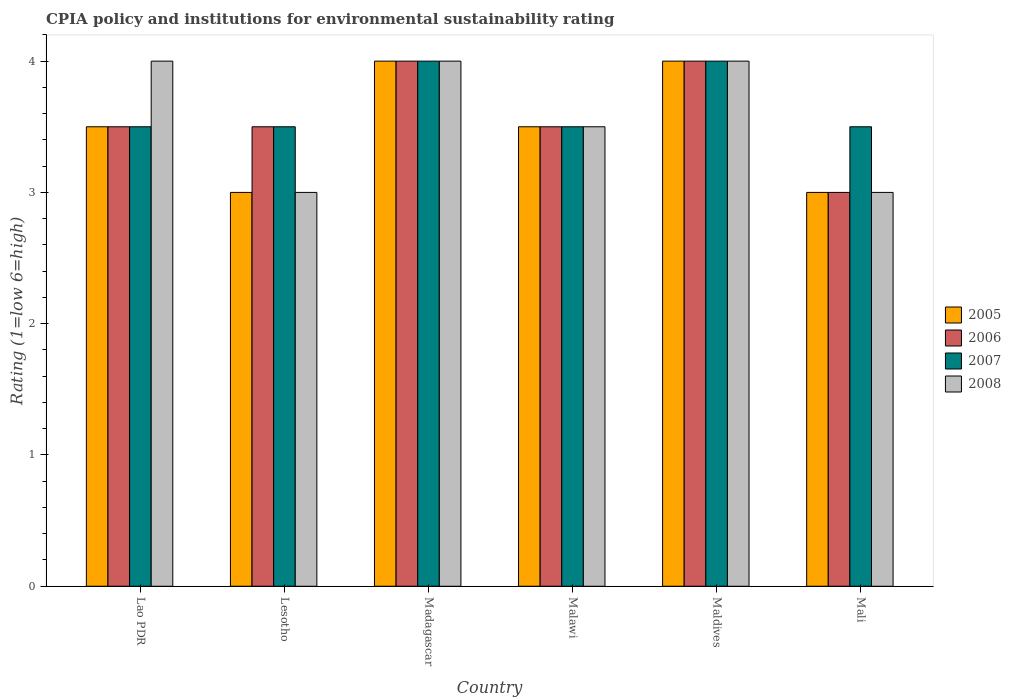How many different coloured bars are there?
Provide a short and direct response. 4. Are the number of bars on each tick of the X-axis equal?
Provide a succinct answer. Yes. How many bars are there on the 5th tick from the left?
Your answer should be compact. 4. How many bars are there on the 5th tick from the right?
Make the answer very short. 4. What is the label of the 4th group of bars from the left?
Offer a very short reply. Malawi. What is the CPIA rating in 2008 in Mali?
Offer a very short reply. 3. In which country was the CPIA rating in 2006 maximum?
Offer a terse response. Madagascar. In which country was the CPIA rating in 2008 minimum?
Give a very brief answer. Lesotho. What is the total CPIA rating in 2005 in the graph?
Keep it short and to the point. 21. What is the difference between the CPIA rating in 2006 in Madagascar and that in Maldives?
Your response must be concise. 0. What is the difference between the CPIA rating in 2007 in Lesotho and the CPIA rating in 2008 in Madagascar?
Give a very brief answer. -0.5. What is the average CPIA rating in 2007 per country?
Your answer should be compact. 3.67. What is the ratio of the CPIA rating in 2006 in Lao PDR to that in Madagascar?
Offer a very short reply. 0.88. Is the difference between the CPIA rating in 2005 in Madagascar and Malawi greater than the difference between the CPIA rating in 2007 in Madagascar and Malawi?
Make the answer very short. No. Is it the case that in every country, the sum of the CPIA rating in 2006 and CPIA rating in 2007 is greater than the sum of CPIA rating in 2005 and CPIA rating in 2008?
Ensure brevity in your answer.  No. What does the 3rd bar from the left in Lao PDR represents?
Keep it short and to the point. 2007. How many bars are there?
Your answer should be very brief. 24. Are all the bars in the graph horizontal?
Provide a short and direct response. No. How many countries are there in the graph?
Offer a terse response. 6. What is the difference between two consecutive major ticks on the Y-axis?
Provide a succinct answer. 1. Are the values on the major ticks of Y-axis written in scientific E-notation?
Your answer should be very brief. No. Does the graph contain any zero values?
Ensure brevity in your answer.  No. Does the graph contain grids?
Give a very brief answer. No. How many legend labels are there?
Offer a terse response. 4. How are the legend labels stacked?
Your answer should be compact. Vertical. What is the title of the graph?
Keep it short and to the point. CPIA policy and institutions for environmental sustainability rating. Does "1990" appear as one of the legend labels in the graph?
Your answer should be very brief. No. What is the label or title of the X-axis?
Ensure brevity in your answer.  Country. What is the label or title of the Y-axis?
Give a very brief answer. Rating (1=low 6=high). What is the Rating (1=low 6=high) of 2005 in Lao PDR?
Keep it short and to the point. 3.5. What is the Rating (1=low 6=high) in 2006 in Lao PDR?
Ensure brevity in your answer.  3.5. What is the Rating (1=low 6=high) in 2008 in Lao PDR?
Offer a very short reply. 4. What is the Rating (1=low 6=high) of 2005 in Lesotho?
Your answer should be very brief. 3. What is the Rating (1=low 6=high) of 2006 in Lesotho?
Make the answer very short. 3.5. What is the Rating (1=low 6=high) of 2007 in Lesotho?
Keep it short and to the point. 3.5. What is the Rating (1=low 6=high) in 2006 in Madagascar?
Give a very brief answer. 4. What is the Rating (1=low 6=high) of 2008 in Madagascar?
Provide a succinct answer. 4. What is the Rating (1=low 6=high) in 2007 in Malawi?
Ensure brevity in your answer.  3.5. What is the Rating (1=low 6=high) in 2008 in Maldives?
Give a very brief answer. 4. What is the Rating (1=low 6=high) in 2006 in Mali?
Ensure brevity in your answer.  3. What is the Rating (1=low 6=high) in 2007 in Mali?
Provide a short and direct response. 3.5. What is the Rating (1=low 6=high) of 2008 in Mali?
Ensure brevity in your answer.  3. Across all countries, what is the maximum Rating (1=low 6=high) in 2005?
Make the answer very short. 4. Across all countries, what is the maximum Rating (1=low 6=high) in 2008?
Your response must be concise. 4. Across all countries, what is the minimum Rating (1=low 6=high) in 2005?
Offer a very short reply. 3. Across all countries, what is the minimum Rating (1=low 6=high) in 2006?
Your answer should be very brief. 3. What is the total Rating (1=low 6=high) in 2005 in the graph?
Make the answer very short. 21. What is the total Rating (1=low 6=high) of 2006 in the graph?
Ensure brevity in your answer.  21.5. What is the difference between the Rating (1=low 6=high) in 2005 in Lao PDR and that in Lesotho?
Your answer should be very brief. 0.5. What is the difference between the Rating (1=low 6=high) of 2008 in Lao PDR and that in Lesotho?
Offer a terse response. 1. What is the difference between the Rating (1=low 6=high) in 2005 in Lao PDR and that in Madagascar?
Offer a very short reply. -0.5. What is the difference between the Rating (1=low 6=high) of 2007 in Lao PDR and that in Madagascar?
Your answer should be very brief. -0.5. What is the difference between the Rating (1=low 6=high) in 2006 in Lao PDR and that in Malawi?
Provide a short and direct response. 0. What is the difference between the Rating (1=low 6=high) of 2007 in Lao PDR and that in Malawi?
Provide a succinct answer. 0. What is the difference between the Rating (1=low 6=high) in 2008 in Lao PDR and that in Maldives?
Give a very brief answer. 0. What is the difference between the Rating (1=low 6=high) of 2005 in Lao PDR and that in Mali?
Offer a terse response. 0.5. What is the difference between the Rating (1=low 6=high) of 2006 in Lao PDR and that in Mali?
Give a very brief answer. 0.5. What is the difference between the Rating (1=low 6=high) in 2005 in Lesotho and that in Madagascar?
Provide a succinct answer. -1. What is the difference between the Rating (1=low 6=high) of 2007 in Lesotho and that in Madagascar?
Provide a short and direct response. -0.5. What is the difference between the Rating (1=low 6=high) in 2005 in Lesotho and that in Malawi?
Your answer should be very brief. -0.5. What is the difference between the Rating (1=low 6=high) in 2007 in Lesotho and that in Malawi?
Ensure brevity in your answer.  0. What is the difference between the Rating (1=low 6=high) in 2006 in Lesotho and that in Maldives?
Your response must be concise. -0.5. What is the difference between the Rating (1=low 6=high) in 2007 in Lesotho and that in Mali?
Offer a very short reply. 0. What is the difference between the Rating (1=low 6=high) of 2008 in Lesotho and that in Mali?
Ensure brevity in your answer.  0. What is the difference between the Rating (1=low 6=high) in 2006 in Madagascar and that in Malawi?
Your answer should be compact. 0.5. What is the difference between the Rating (1=low 6=high) of 2007 in Madagascar and that in Malawi?
Give a very brief answer. 0.5. What is the difference between the Rating (1=low 6=high) in 2008 in Madagascar and that in Malawi?
Provide a succinct answer. 0.5. What is the difference between the Rating (1=low 6=high) in 2006 in Madagascar and that in Maldives?
Keep it short and to the point. 0. What is the difference between the Rating (1=low 6=high) in 2007 in Madagascar and that in Maldives?
Provide a succinct answer. 0. What is the difference between the Rating (1=low 6=high) of 2008 in Madagascar and that in Mali?
Offer a terse response. 1. What is the difference between the Rating (1=low 6=high) in 2005 in Malawi and that in Maldives?
Keep it short and to the point. -0.5. What is the difference between the Rating (1=low 6=high) in 2006 in Malawi and that in Maldives?
Offer a very short reply. -0.5. What is the difference between the Rating (1=low 6=high) in 2008 in Malawi and that in Maldives?
Provide a succinct answer. -0.5. What is the difference between the Rating (1=low 6=high) in 2005 in Malawi and that in Mali?
Give a very brief answer. 0.5. What is the difference between the Rating (1=low 6=high) in 2006 in Malawi and that in Mali?
Offer a very short reply. 0.5. What is the difference between the Rating (1=low 6=high) of 2007 in Malawi and that in Mali?
Provide a succinct answer. 0. What is the difference between the Rating (1=low 6=high) of 2008 in Malawi and that in Mali?
Provide a succinct answer. 0.5. What is the difference between the Rating (1=low 6=high) in 2005 in Lao PDR and the Rating (1=low 6=high) in 2006 in Lesotho?
Provide a short and direct response. 0. What is the difference between the Rating (1=low 6=high) in 2005 in Lao PDR and the Rating (1=low 6=high) in 2007 in Madagascar?
Your answer should be very brief. -0.5. What is the difference between the Rating (1=low 6=high) in 2006 in Lao PDR and the Rating (1=low 6=high) in 2008 in Madagascar?
Make the answer very short. -0.5. What is the difference between the Rating (1=low 6=high) in 2007 in Lao PDR and the Rating (1=low 6=high) in 2008 in Madagascar?
Your answer should be very brief. -0.5. What is the difference between the Rating (1=low 6=high) in 2005 in Lao PDR and the Rating (1=low 6=high) in 2007 in Malawi?
Your response must be concise. 0. What is the difference between the Rating (1=low 6=high) in 2006 in Lao PDR and the Rating (1=low 6=high) in 2008 in Malawi?
Keep it short and to the point. 0. What is the difference between the Rating (1=low 6=high) in 2006 in Lao PDR and the Rating (1=low 6=high) in 2008 in Maldives?
Your answer should be very brief. -0.5. What is the difference between the Rating (1=low 6=high) in 2007 in Lao PDR and the Rating (1=low 6=high) in 2008 in Maldives?
Offer a very short reply. -0.5. What is the difference between the Rating (1=low 6=high) of 2005 in Lao PDR and the Rating (1=low 6=high) of 2007 in Mali?
Your answer should be compact. 0. What is the difference between the Rating (1=low 6=high) of 2005 in Lao PDR and the Rating (1=low 6=high) of 2008 in Mali?
Make the answer very short. 0.5. What is the difference between the Rating (1=low 6=high) in 2006 in Lao PDR and the Rating (1=low 6=high) in 2007 in Mali?
Your response must be concise. 0. What is the difference between the Rating (1=low 6=high) in 2006 in Lao PDR and the Rating (1=low 6=high) in 2008 in Mali?
Provide a short and direct response. 0.5. What is the difference between the Rating (1=low 6=high) in 2007 in Lao PDR and the Rating (1=low 6=high) in 2008 in Mali?
Make the answer very short. 0.5. What is the difference between the Rating (1=low 6=high) of 2005 in Lesotho and the Rating (1=low 6=high) of 2006 in Madagascar?
Your response must be concise. -1. What is the difference between the Rating (1=low 6=high) in 2005 in Lesotho and the Rating (1=low 6=high) in 2007 in Madagascar?
Your response must be concise. -1. What is the difference between the Rating (1=low 6=high) of 2005 in Lesotho and the Rating (1=low 6=high) of 2008 in Madagascar?
Provide a short and direct response. -1. What is the difference between the Rating (1=low 6=high) of 2006 in Lesotho and the Rating (1=low 6=high) of 2008 in Madagascar?
Your response must be concise. -0.5. What is the difference between the Rating (1=low 6=high) in 2005 in Lesotho and the Rating (1=low 6=high) in 2007 in Malawi?
Provide a short and direct response. -0.5. What is the difference between the Rating (1=low 6=high) in 2005 in Lesotho and the Rating (1=low 6=high) in 2008 in Malawi?
Offer a terse response. -0.5. What is the difference between the Rating (1=low 6=high) of 2006 in Lesotho and the Rating (1=low 6=high) of 2008 in Malawi?
Provide a succinct answer. 0. What is the difference between the Rating (1=low 6=high) of 2007 in Lesotho and the Rating (1=low 6=high) of 2008 in Malawi?
Your response must be concise. 0. What is the difference between the Rating (1=low 6=high) of 2005 in Lesotho and the Rating (1=low 6=high) of 2007 in Maldives?
Offer a terse response. -1. What is the difference between the Rating (1=low 6=high) in 2006 in Lesotho and the Rating (1=low 6=high) in 2007 in Maldives?
Give a very brief answer. -0.5. What is the difference between the Rating (1=low 6=high) of 2006 in Lesotho and the Rating (1=low 6=high) of 2008 in Maldives?
Your response must be concise. -0.5. What is the difference between the Rating (1=low 6=high) of 2005 in Lesotho and the Rating (1=low 6=high) of 2006 in Mali?
Give a very brief answer. 0. What is the difference between the Rating (1=low 6=high) in 2005 in Lesotho and the Rating (1=low 6=high) in 2007 in Mali?
Offer a very short reply. -0.5. What is the difference between the Rating (1=low 6=high) in 2007 in Lesotho and the Rating (1=low 6=high) in 2008 in Mali?
Your answer should be compact. 0.5. What is the difference between the Rating (1=low 6=high) of 2005 in Madagascar and the Rating (1=low 6=high) of 2006 in Malawi?
Your answer should be compact. 0.5. What is the difference between the Rating (1=low 6=high) of 2005 in Madagascar and the Rating (1=low 6=high) of 2007 in Malawi?
Make the answer very short. 0.5. What is the difference between the Rating (1=low 6=high) of 2005 in Madagascar and the Rating (1=low 6=high) of 2008 in Malawi?
Provide a succinct answer. 0.5. What is the difference between the Rating (1=low 6=high) of 2006 in Madagascar and the Rating (1=low 6=high) of 2007 in Maldives?
Your answer should be compact. 0. What is the difference between the Rating (1=low 6=high) in 2006 in Madagascar and the Rating (1=low 6=high) in 2008 in Maldives?
Give a very brief answer. 0. What is the difference between the Rating (1=low 6=high) of 2005 in Madagascar and the Rating (1=low 6=high) of 2008 in Mali?
Keep it short and to the point. 1. What is the difference between the Rating (1=low 6=high) in 2006 in Madagascar and the Rating (1=low 6=high) in 2007 in Mali?
Make the answer very short. 0.5. What is the difference between the Rating (1=low 6=high) in 2006 in Madagascar and the Rating (1=low 6=high) in 2008 in Mali?
Your answer should be compact. 1. What is the difference between the Rating (1=low 6=high) of 2005 in Malawi and the Rating (1=low 6=high) of 2006 in Maldives?
Give a very brief answer. -0.5. What is the difference between the Rating (1=low 6=high) in 2005 in Malawi and the Rating (1=low 6=high) in 2007 in Maldives?
Ensure brevity in your answer.  -0.5. What is the difference between the Rating (1=low 6=high) in 2005 in Malawi and the Rating (1=low 6=high) in 2008 in Maldives?
Keep it short and to the point. -0.5. What is the difference between the Rating (1=low 6=high) of 2005 in Malawi and the Rating (1=low 6=high) of 2007 in Mali?
Ensure brevity in your answer.  0. What is the difference between the Rating (1=low 6=high) in 2006 in Malawi and the Rating (1=low 6=high) in 2007 in Mali?
Offer a very short reply. 0. What is the difference between the Rating (1=low 6=high) in 2006 in Malawi and the Rating (1=low 6=high) in 2008 in Mali?
Your answer should be very brief. 0.5. What is the difference between the Rating (1=low 6=high) of 2005 in Maldives and the Rating (1=low 6=high) of 2008 in Mali?
Ensure brevity in your answer.  1. What is the difference between the Rating (1=low 6=high) in 2006 in Maldives and the Rating (1=low 6=high) in 2008 in Mali?
Your answer should be compact. 1. What is the average Rating (1=low 6=high) of 2005 per country?
Your answer should be very brief. 3.5. What is the average Rating (1=low 6=high) of 2006 per country?
Your response must be concise. 3.58. What is the average Rating (1=low 6=high) of 2007 per country?
Provide a succinct answer. 3.67. What is the average Rating (1=low 6=high) in 2008 per country?
Provide a succinct answer. 3.58. What is the difference between the Rating (1=low 6=high) of 2005 and Rating (1=low 6=high) of 2006 in Lao PDR?
Provide a succinct answer. 0. What is the difference between the Rating (1=low 6=high) in 2005 and Rating (1=low 6=high) in 2007 in Lao PDR?
Keep it short and to the point. 0. What is the difference between the Rating (1=low 6=high) of 2005 and Rating (1=low 6=high) of 2008 in Lao PDR?
Give a very brief answer. -0.5. What is the difference between the Rating (1=low 6=high) in 2006 and Rating (1=low 6=high) in 2007 in Lao PDR?
Your response must be concise. 0. What is the difference between the Rating (1=low 6=high) of 2007 and Rating (1=low 6=high) of 2008 in Lao PDR?
Provide a short and direct response. -0.5. What is the difference between the Rating (1=low 6=high) in 2005 and Rating (1=low 6=high) in 2008 in Lesotho?
Give a very brief answer. 0. What is the difference between the Rating (1=low 6=high) of 2006 and Rating (1=low 6=high) of 2007 in Lesotho?
Provide a short and direct response. 0. What is the difference between the Rating (1=low 6=high) in 2007 and Rating (1=low 6=high) in 2008 in Lesotho?
Make the answer very short. 0.5. What is the difference between the Rating (1=low 6=high) of 2006 and Rating (1=low 6=high) of 2007 in Madagascar?
Offer a very short reply. 0. What is the difference between the Rating (1=low 6=high) of 2006 and Rating (1=low 6=high) of 2008 in Madagascar?
Keep it short and to the point. 0. What is the difference between the Rating (1=low 6=high) in 2006 and Rating (1=low 6=high) in 2007 in Malawi?
Provide a succinct answer. 0. What is the difference between the Rating (1=low 6=high) in 2006 and Rating (1=low 6=high) in 2008 in Malawi?
Keep it short and to the point. 0. What is the difference between the Rating (1=low 6=high) of 2007 and Rating (1=low 6=high) of 2008 in Malawi?
Your answer should be compact. 0. What is the difference between the Rating (1=low 6=high) in 2006 and Rating (1=low 6=high) in 2008 in Maldives?
Your answer should be compact. 0. What is the difference between the Rating (1=low 6=high) in 2005 and Rating (1=low 6=high) in 2007 in Mali?
Keep it short and to the point. -0.5. What is the difference between the Rating (1=low 6=high) of 2005 and Rating (1=low 6=high) of 2008 in Mali?
Your answer should be compact. 0. What is the difference between the Rating (1=low 6=high) of 2007 and Rating (1=low 6=high) of 2008 in Mali?
Offer a terse response. 0.5. What is the ratio of the Rating (1=low 6=high) of 2006 in Lao PDR to that in Lesotho?
Your answer should be very brief. 1. What is the ratio of the Rating (1=low 6=high) in 2005 in Lao PDR to that in Madagascar?
Offer a very short reply. 0.88. What is the ratio of the Rating (1=low 6=high) in 2005 in Lao PDR to that in Malawi?
Make the answer very short. 1. What is the ratio of the Rating (1=low 6=high) of 2006 in Lao PDR to that in Malawi?
Give a very brief answer. 1. What is the ratio of the Rating (1=low 6=high) in 2006 in Lao PDR to that in Maldives?
Your answer should be compact. 0.88. What is the ratio of the Rating (1=low 6=high) of 2008 in Lao PDR to that in Maldives?
Keep it short and to the point. 1. What is the ratio of the Rating (1=low 6=high) in 2005 in Lao PDR to that in Mali?
Your answer should be very brief. 1.17. What is the ratio of the Rating (1=low 6=high) of 2006 in Lao PDR to that in Mali?
Provide a succinct answer. 1.17. What is the ratio of the Rating (1=low 6=high) of 2007 in Lao PDR to that in Mali?
Your response must be concise. 1. What is the ratio of the Rating (1=low 6=high) of 2008 in Lesotho to that in Madagascar?
Provide a short and direct response. 0.75. What is the ratio of the Rating (1=low 6=high) in 2005 in Lesotho to that in Malawi?
Make the answer very short. 0.86. What is the ratio of the Rating (1=low 6=high) in 2008 in Lesotho to that in Malawi?
Ensure brevity in your answer.  0.86. What is the ratio of the Rating (1=low 6=high) of 2006 in Lesotho to that in Maldives?
Your response must be concise. 0.88. What is the ratio of the Rating (1=low 6=high) in 2007 in Lesotho to that in Maldives?
Provide a succinct answer. 0.88. What is the ratio of the Rating (1=low 6=high) of 2005 in Lesotho to that in Mali?
Make the answer very short. 1. What is the ratio of the Rating (1=low 6=high) of 2007 in Lesotho to that in Mali?
Your answer should be very brief. 1. What is the ratio of the Rating (1=low 6=high) of 2008 in Lesotho to that in Mali?
Provide a succinct answer. 1. What is the ratio of the Rating (1=low 6=high) of 2005 in Madagascar to that in Malawi?
Keep it short and to the point. 1.14. What is the ratio of the Rating (1=low 6=high) in 2006 in Madagascar to that in Malawi?
Provide a succinct answer. 1.14. What is the ratio of the Rating (1=low 6=high) of 2005 in Madagascar to that in Maldives?
Provide a short and direct response. 1. What is the ratio of the Rating (1=low 6=high) in 2006 in Madagascar to that in Maldives?
Offer a very short reply. 1. What is the ratio of the Rating (1=low 6=high) of 2007 in Madagascar to that in Maldives?
Make the answer very short. 1. What is the ratio of the Rating (1=low 6=high) of 2008 in Madagascar to that in Maldives?
Give a very brief answer. 1. What is the ratio of the Rating (1=low 6=high) in 2005 in Madagascar to that in Mali?
Ensure brevity in your answer.  1.33. What is the ratio of the Rating (1=low 6=high) in 2008 in Madagascar to that in Mali?
Provide a short and direct response. 1.33. What is the ratio of the Rating (1=low 6=high) of 2005 in Malawi to that in Maldives?
Give a very brief answer. 0.88. What is the ratio of the Rating (1=low 6=high) of 2005 in Malawi to that in Mali?
Make the answer very short. 1.17. What is the ratio of the Rating (1=low 6=high) in 2005 in Maldives to that in Mali?
Offer a very short reply. 1.33. What is the ratio of the Rating (1=low 6=high) in 2006 in Maldives to that in Mali?
Give a very brief answer. 1.33. What is the difference between the highest and the second highest Rating (1=low 6=high) of 2005?
Your response must be concise. 0. What is the difference between the highest and the second highest Rating (1=low 6=high) in 2007?
Your response must be concise. 0. What is the difference between the highest and the second highest Rating (1=low 6=high) in 2008?
Ensure brevity in your answer.  0. What is the difference between the highest and the lowest Rating (1=low 6=high) of 2005?
Your answer should be very brief. 1. What is the difference between the highest and the lowest Rating (1=low 6=high) of 2006?
Make the answer very short. 1. What is the difference between the highest and the lowest Rating (1=low 6=high) of 2007?
Your answer should be very brief. 0.5. 